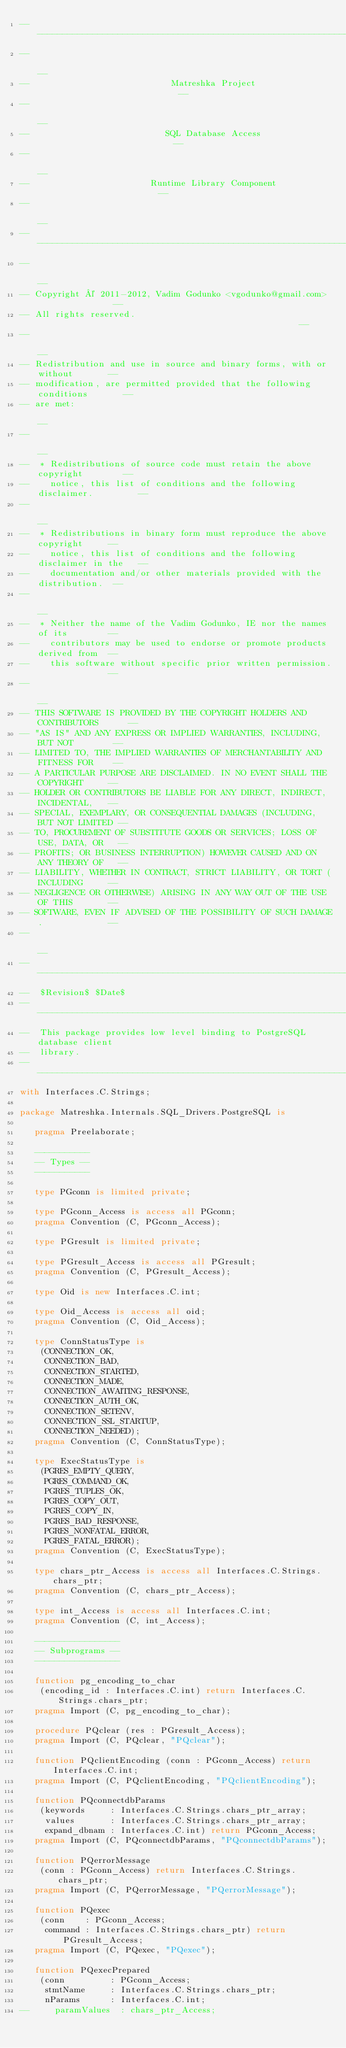Convert code to text. <code><loc_0><loc_0><loc_500><loc_500><_Ada_>------------------------------------------------------------------------------
--                                                                          --
--                            Matreshka Project                             --
--                                                                          --
--                           SQL Database Access                            --
--                                                                          --
--                        Runtime Library Component                         --
--                                                                          --
------------------------------------------------------------------------------
--                                                                          --
-- Copyright © 2011-2012, Vadim Godunko <vgodunko@gmail.com>                --
-- All rights reserved.                                                     --
--                                                                          --
-- Redistribution and use in source and binary forms, with or without       --
-- modification, are permitted provided that the following conditions       --
-- are met:                                                                 --
--                                                                          --
--  * Redistributions of source code must retain the above copyright        --
--    notice, this list of conditions and the following disclaimer.         --
--                                                                          --
--  * Redistributions in binary form must reproduce the above copyright     --
--    notice, this list of conditions and the following disclaimer in the   --
--    documentation and/or other materials provided with the distribution.  --
--                                                                          --
--  * Neither the name of the Vadim Godunko, IE nor the names of its        --
--    contributors may be used to endorse or promote products derived from  --
--    this software without specific prior written permission.              --
--                                                                          --
-- THIS SOFTWARE IS PROVIDED BY THE COPYRIGHT HOLDERS AND CONTRIBUTORS      --
-- "AS IS" AND ANY EXPRESS OR IMPLIED WARRANTIES, INCLUDING, BUT NOT        --
-- LIMITED TO, THE IMPLIED WARRANTIES OF MERCHANTABILITY AND FITNESS FOR    --
-- A PARTICULAR PURPOSE ARE DISCLAIMED. IN NO EVENT SHALL THE COPYRIGHT     --
-- HOLDER OR CONTRIBUTORS BE LIABLE FOR ANY DIRECT, INDIRECT, INCIDENTAL,   --
-- SPECIAL, EXEMPLARY, OR CONSEQUENTIAL DAMAGES (INCLUDING, BUT NOT LIMITED --
-- TO, PROCUREMENT OF SUBSTITUTE GOODS OR SERVICES; LOSS OF USE, DATA, OR   --
-- PROFITS; OR BUSINESS INTERRUPTION) HOWEVER CAUSED AND ON ANY THEORY OF   --
-- LIABILITY, WHETHER IN CONTRACT, STRICT LIABILITY, OR TORT (INCLUDING     --
-- NEGLIGENCE OR OTHERWISE) ARISING IN ANY WAY OUT OF THE USE OF THIS       --
-- SOFTWARE, EVEN IF ADVISED OF THE POSSIBILITY OF SUCH DAMAGE.             --
--                                                                          --
------------------------------------------------------------------------------
--  $Revision$ $Date$
------------------------------------------------------------------------------
--  This package provides low level binding to PostgreSQL database client
--  library.
------------------------------------------------------------------------------
with Interfaces.C.Strings;

package Matreshka.Internals.SQL_Drivers.PostgreSQL is

   pragma Preelaborate;

   -----------
   -- Types --
   -----------

   type PGconn is limited private;

   type PGconn_Access is access all PGconn;
   pragma Convention (C, PGconn_Access);

   type PGresult is limited private;

   type PGresult_Access is access all PGresult;
   pragma Convention (C, PGresult_Access);

   type Oid is new Interfaces.C.int;

   type Oid_Access is access all oid;
   pragma Convention (C, Oid_Access);

   type ConnStatusType is
    (CONNECTION_OK,
     CONNECTION_BAD,
     CONNECTION_STARTED,
     CONNECTION_MADE,
     CONNECTION_AWAITING_RESPONSE,
     CONNECTION_AUTH_OK,
     CONNECTION_SETENV,
     CONNECTION_SSL_STARTUP,
     CONNECTION_NEEDED);
   pragma Convention (C, ConnStatusType);

   type ExecStatusType is
    (PGRES_EMPTY_QUERY,
     PGRES_COMMAND_OK,
     PGRES_TUPLES_OK,
     PGRES_COPY_OUT,
     PGRES_COPY_IN,
     PGRES_BAD_RESPONSE,
     PGRES_NONFATAL_ERROR,
     PGRES_FATAL_ERROR);
   pragma Convention (C, ExecStatusType);

   type chars_ptr_Access is access all Interfaces.C.Strings.chars_ptr;
   pragma Convention (C, chars_ptr_Access);

   type int_Access is access all Interfaces.C.int;
   pragma Convention (C, int_Access);

   -----------------
   -- Subprograms --
   -----------------

   function pg_encoding_to_char
    (encoding_id : Interfaces.C.int) return Interfaces.C.Strings.chars_ptr;
   pragma Import (C, pg_encoding_to_char);

   procedure PQclear (res : PGresult_Access);
   pragma Import (C, PQclear, "PQclear");

   function PQclientEncoding (conn : PGconn_Access) return Interfaces.C.int;
   pragma Import (C, PQclientEncoding, "PQclientEncoding");

   function PQconnectdbParams
    (keywords     : Interfaces.C.Strings.chars_ptr_array;
     values       : Interfaces.C.Strings.chars_ptr_array;
     expand_dbnam : Interfaces.C.int) return PGconn_Access;
   pragma Import (C, PQconnectdbParams, "PQconnectdbParams");

   function PQerrorMessage
    (conn : PGconn_Access) return Interfaces.C.Strings.chars_ptr;
   pragma Import (C, PQerrorMessage, "PQerrorMessage");

   function PQexec
    (conn    : PGconn_Access;
     command : Interfaces.C.Strings.chars_ptr) return PGresult_Access;
   pragma Import (C, PQexec, "PQexec");

   function PQexecPrepared
    (conn         : PGconn_Access;
     stmtName     : Interfaces.C.Strings.chars_ptr;
     nParams      : Interfaces.C.int;
--     paramValues  : chars_ptr_Access;</code> 